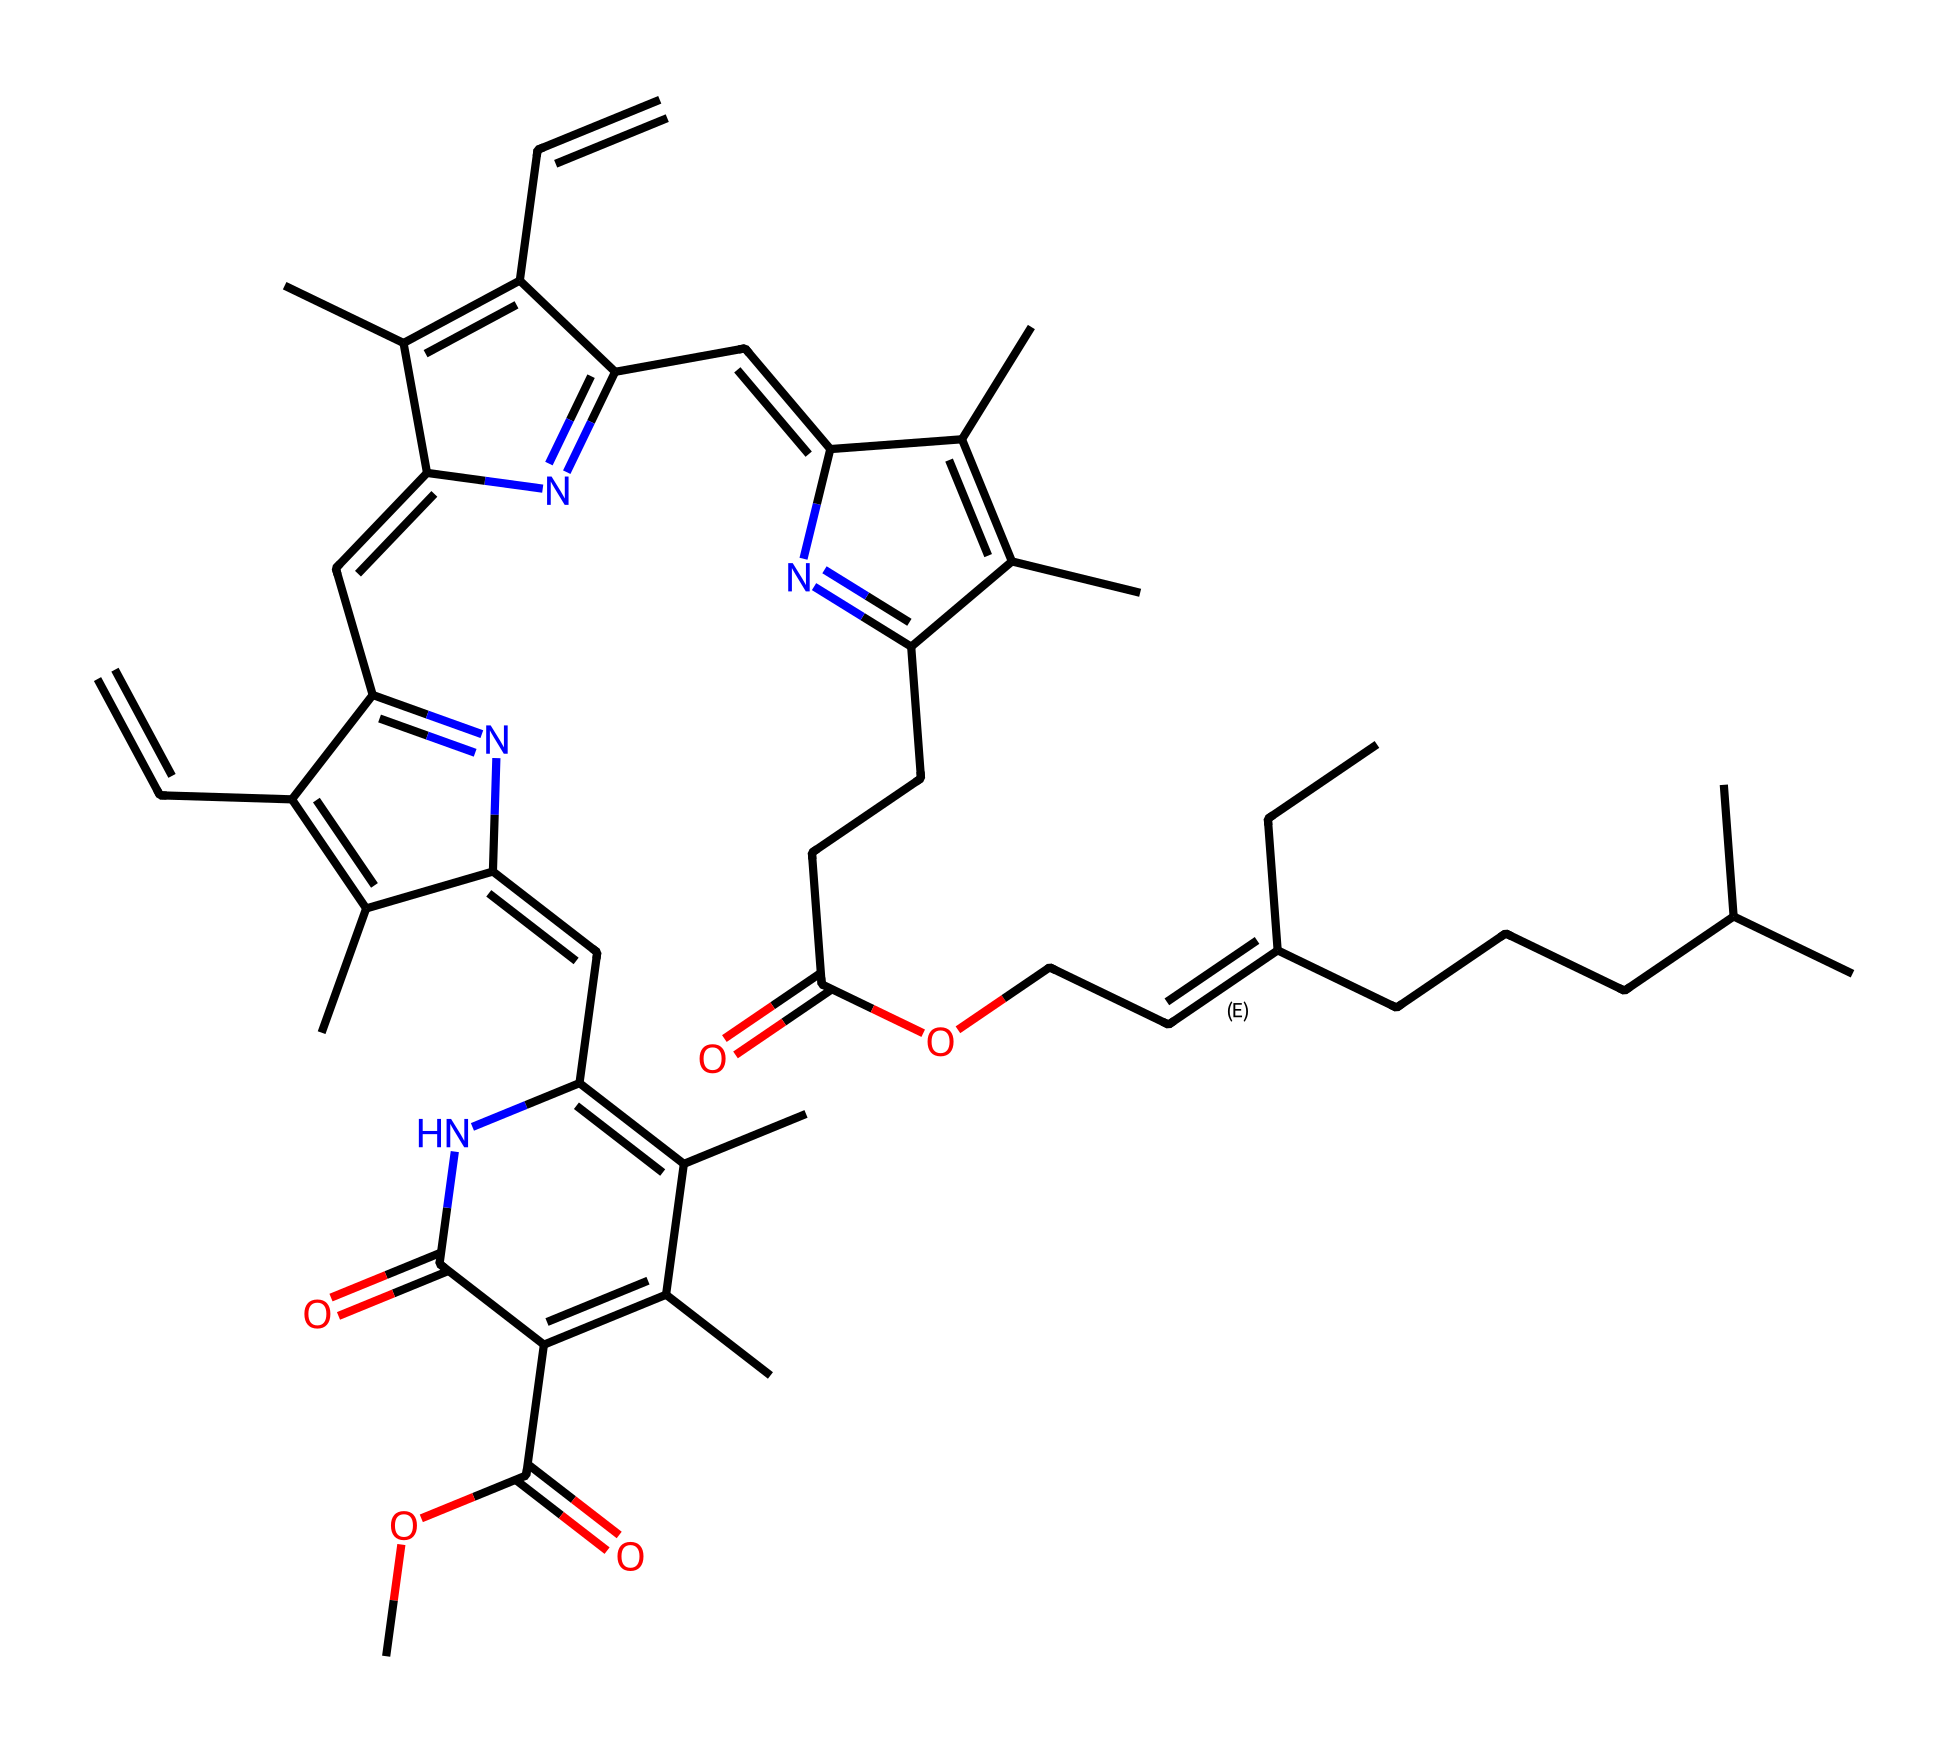What is the molecular formula of chlorophyll as represented in the SMILES? The SMILES representation encodes both atom types and their counts; examining it, we identify carbon (C), hydrogen (H), nitrogen (N), and oxygen (O) atoms. By counting, we find 55 carbons, 72 hydrogens, 5 nitrogens, and 6 oxygens, which together constitute the molecular formula C55H72N4O6.
Answer: C55H72N4O6 How many rings are present in the chemical structure? Analyzing the structure denoted by the SMILES, we identify several interconnected cyclic systems. Notably, there are four distinct ring structures connected by double bonds, each characterized by planar arrangements, coming from the alternating carbon-carbon bonds. The total count is four rings.
Answer: 4 Which functional groups can be identified in this chlorophyll molecule? By reviewing the SMILES for distinctive features, we note several functional groups: hydroxyl (-OH), carbonyl (C=O), and amine (C-N). These groups are involved in the molecule's reactivity and functionality, identified through their placements in the structure.
Answer: hydroxyl, carbonyl, amine What role does the nitrogen atom play in the chlorophyll structure? In the chlorophyll structure, each nitrogen atom is part of a pyrrole-like ring system that stabilizes the electronic structure of the molecule, attributed to its ability to coordinate with metal ions, particularly magnesium, which is essential for its function in photosynthesis.
Answer: coordination How many carbon atoms are in the longest continuous chain within the chlorophyll molecule? To determine the longest continuous carbon chain, we trace the connections, identifying that the longest stretch of bonded carbons is 15. This sequential counting demonstrates that chlorophyll has a significant hydrocarbon backbone essential for its structural integrity.
Answer: 15 What type of light does chlorophyll primarily absorb? Chlorophyll primarily absorbs blue and red portions of the light spectrum. This can be understood from its structural composition, as the chromophore regions within absorb specific wavelengths for optimal photosynthesis activity, particularly around 430 nm and 665 nm.
Answer: blue and red 